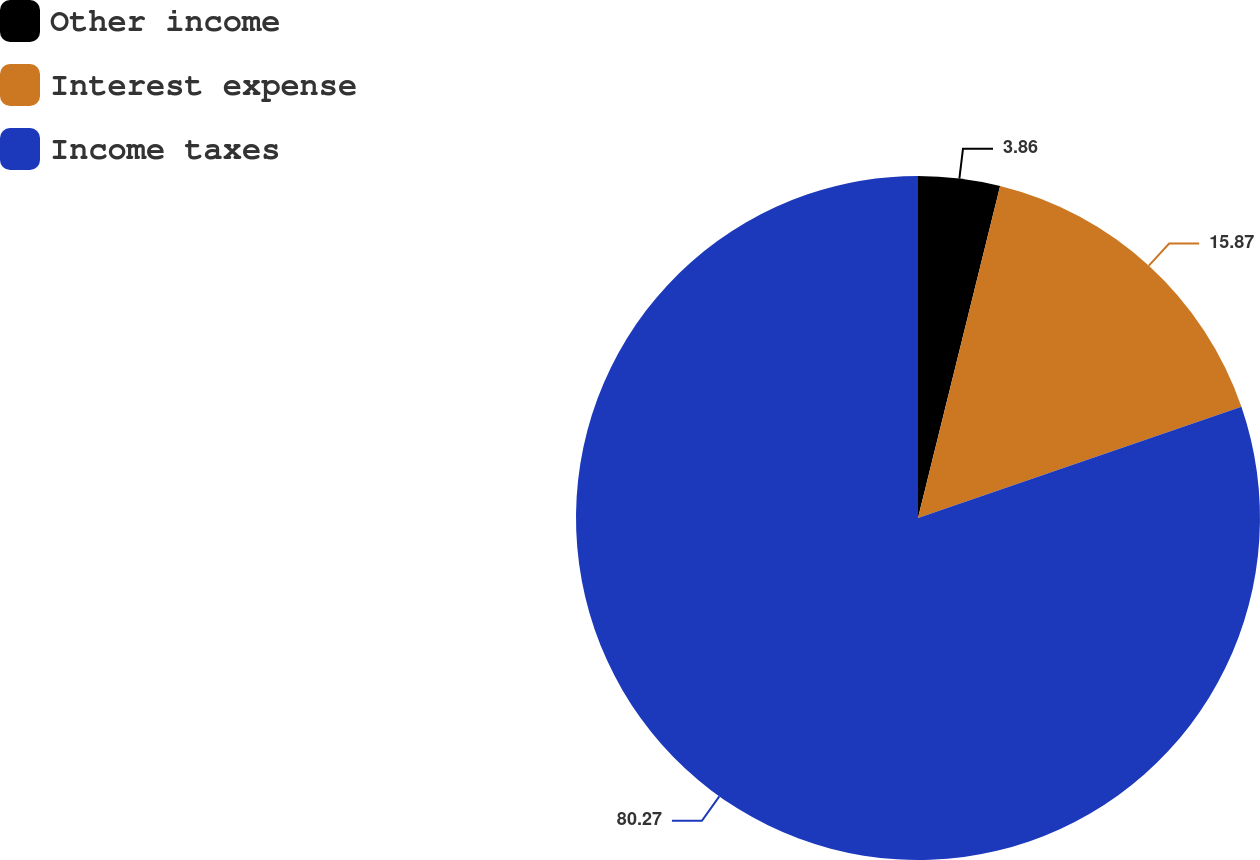<chart> <loc_0><loc_0><loc_500><loc_500><pie_chart><fcel>Other income<fcel>Interest expense<fcel>Income taxes<nl><fcel>3.86%<fcel>15.87%<fcel>80.27%<nl></chart> 